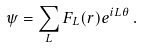<formula> <loc_0><loc_0><loc_500><loc_500>\psi = \sum _ { L } F _ { L } ( r ) e ^ { i L \theta } \, .</formula> 